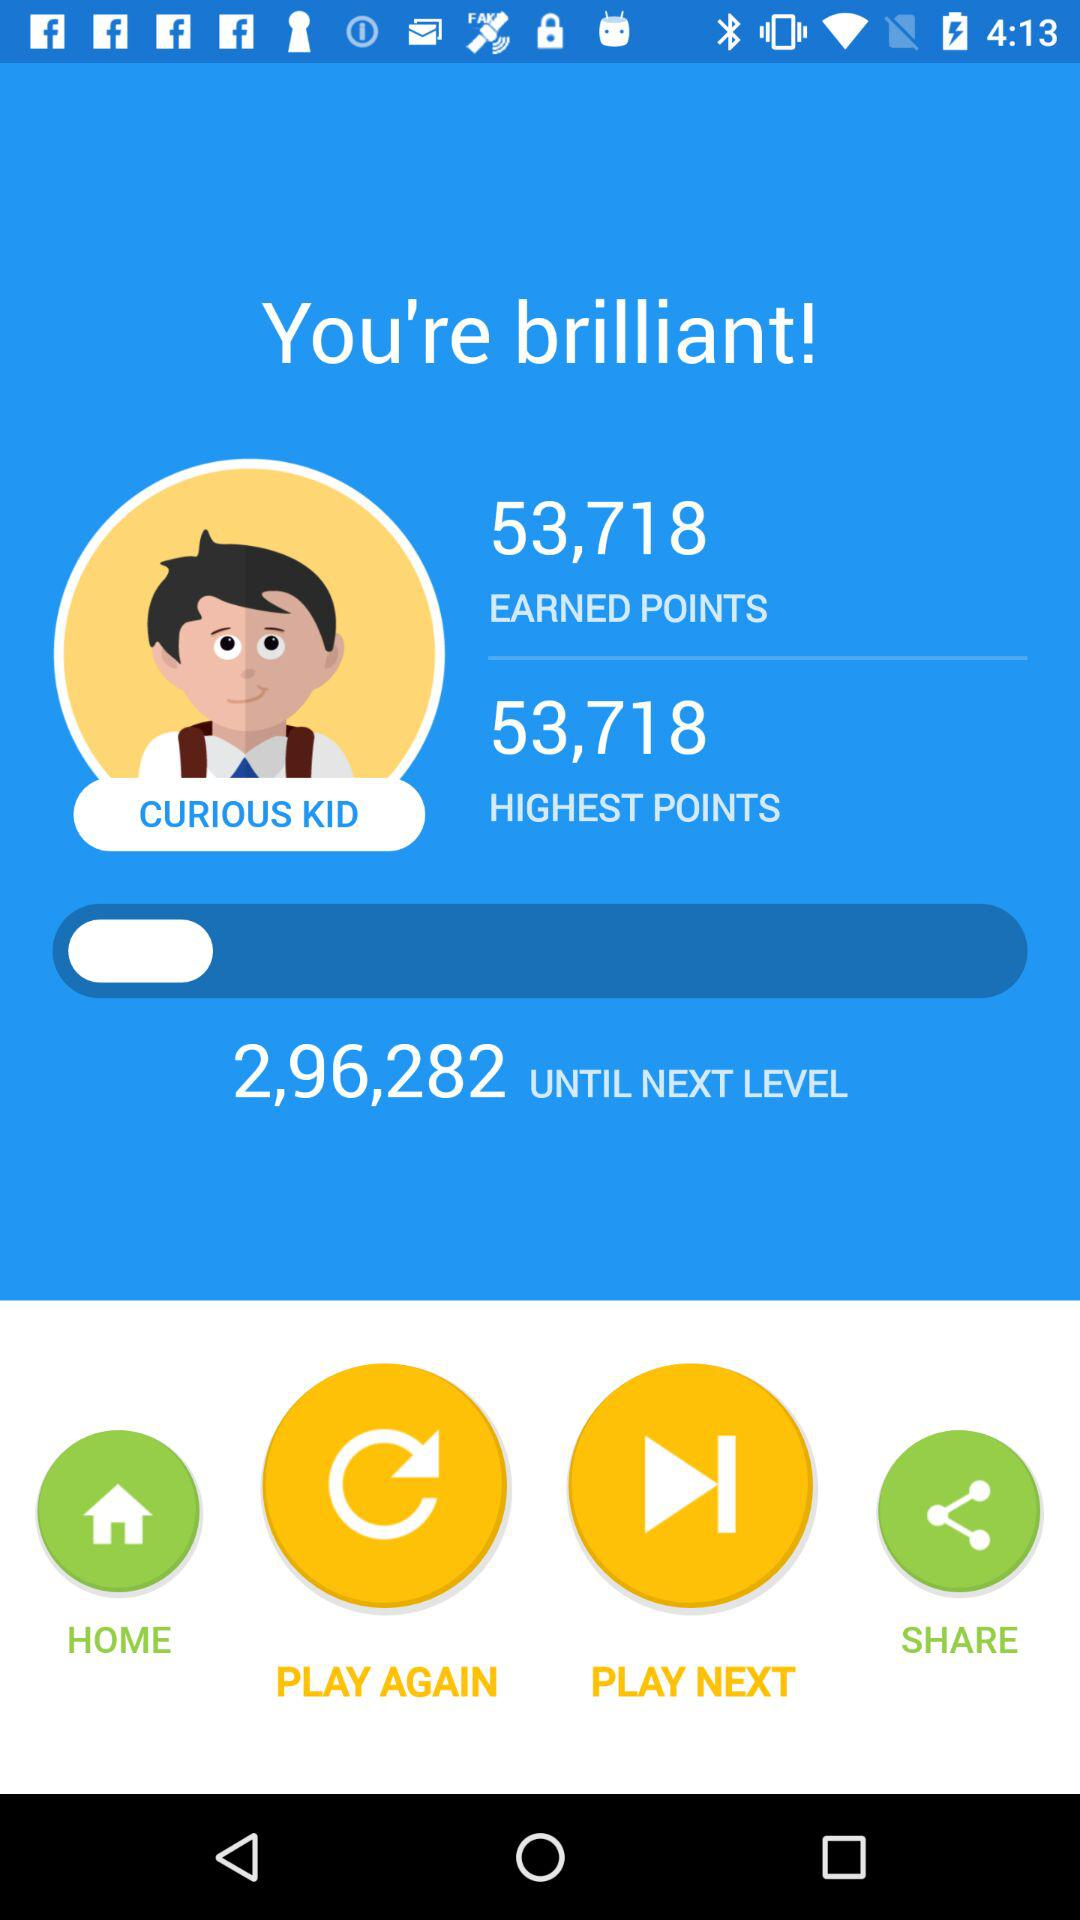How many points have I earned?
Answer the question using a single word or phrase. 53,718 